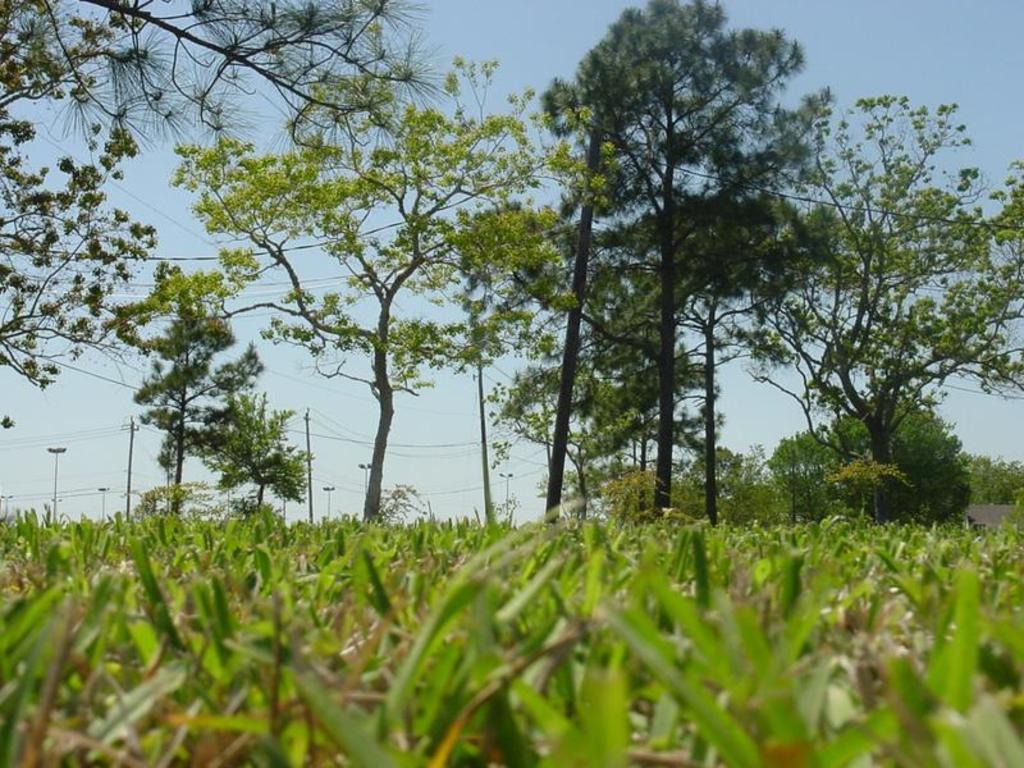Describe this image in one or two sentences. There is cattle at the front. There are trees at the back and there are electric poles and wires behind them. 